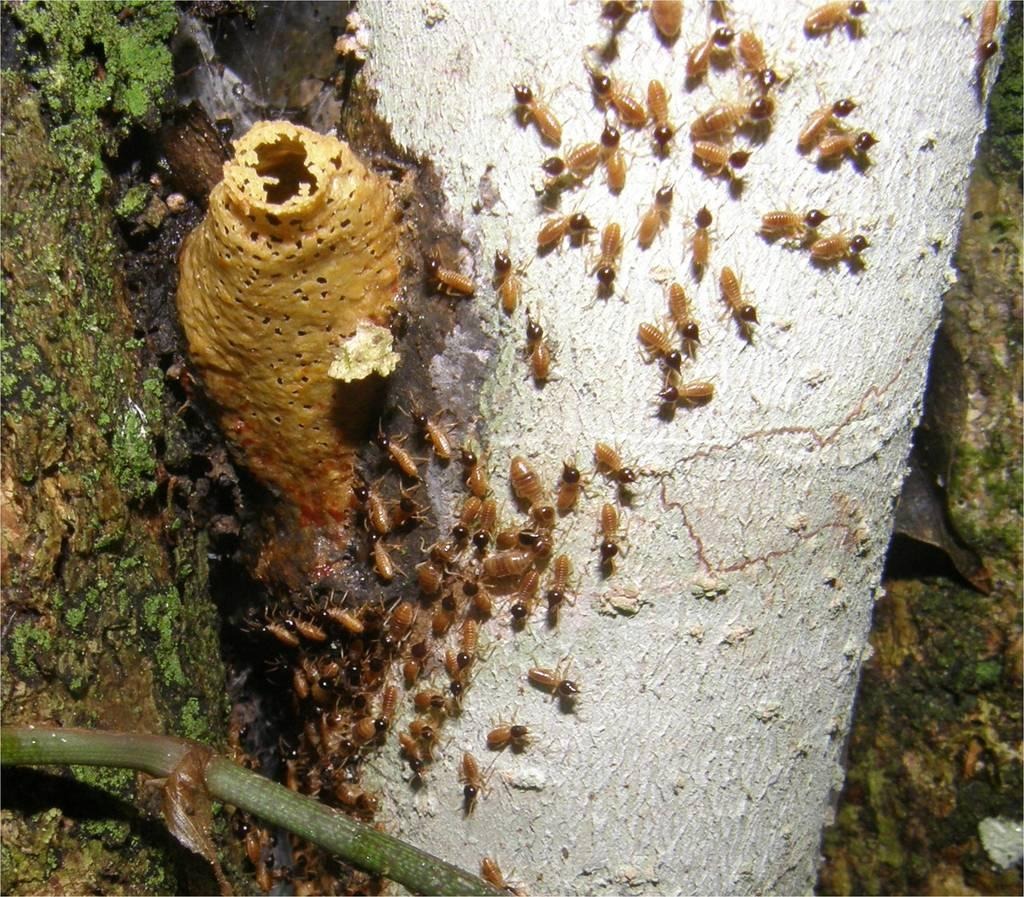What type of creatures are present in the image? There are cream-colored insects in the image. What can be seen in the background of the image? There is a tree trunk visible in the background of the image. What type of wax is being used to create the leather texture on the kite in the image? There is no kite or leather texture present in the image; it features cream-colored insects and a tree trunk in the background. 